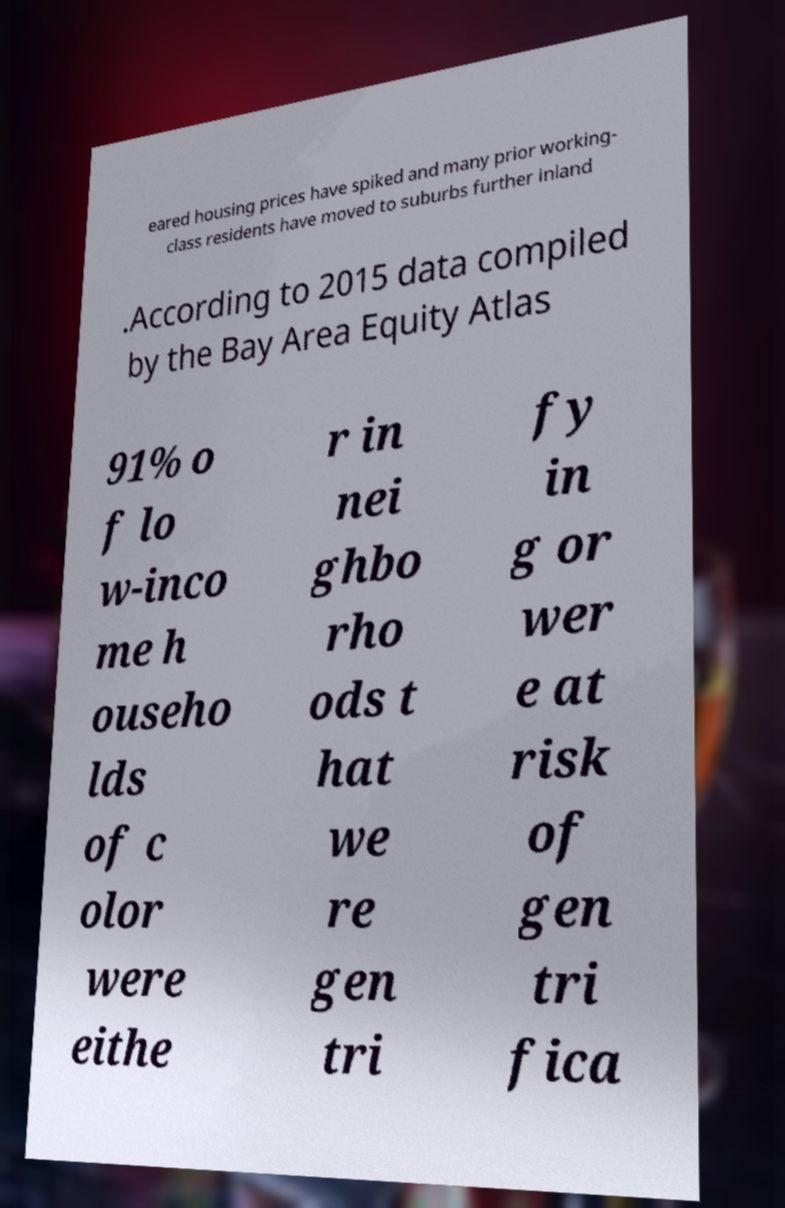Could you assist in decoding the text presented in this image and type it out clearly? eared housing prices have spiked and many prior working- class residents have moved to suburbs further inland .According to 2015 data compiled by the Bay Area Equity Atlas 91% o f lo w-inco me h ouseho lds of c olor were eithe r in nei ghbo rho ods t hat we re gen tri fy in g or wer e at risk of gen tri fica 